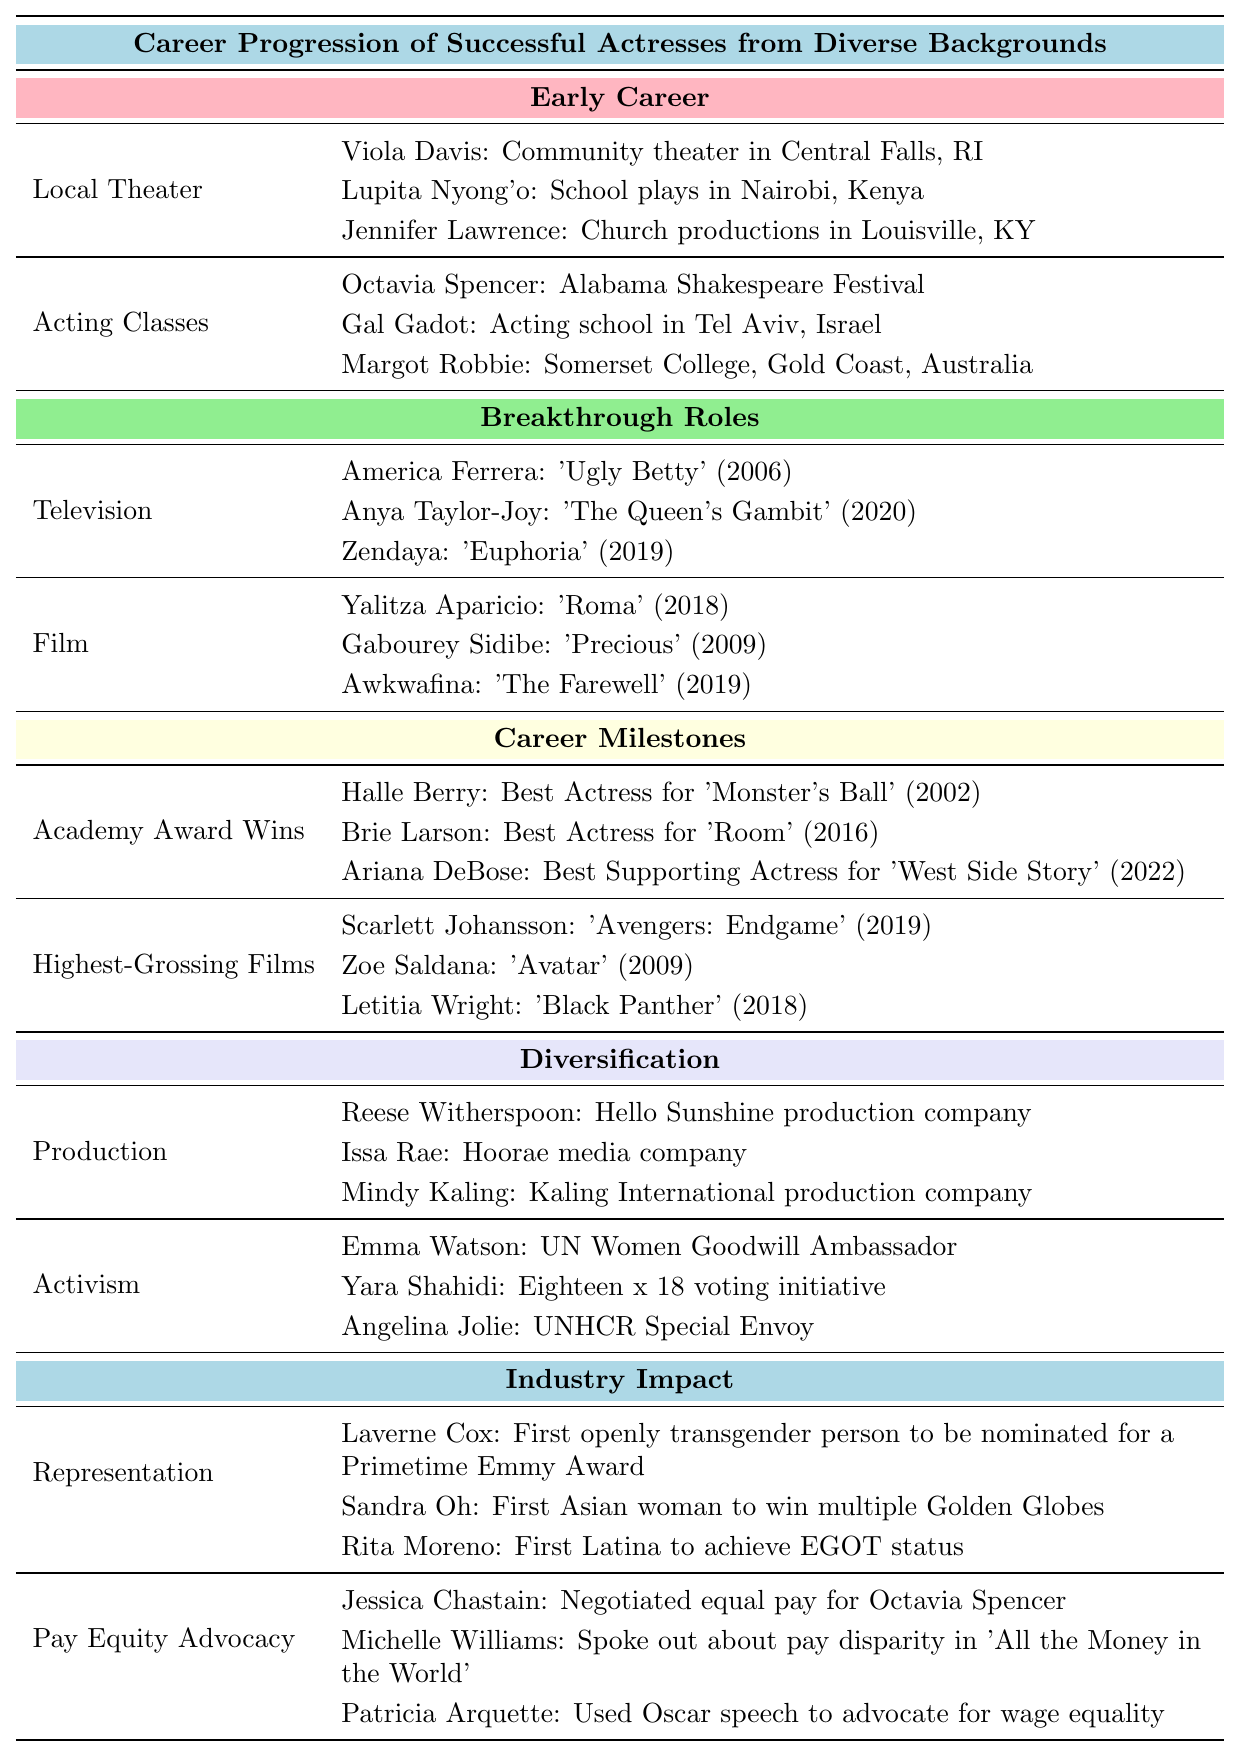What stages are included in the early career section? The early career section lists two stages: Local Theater and Acting Classes. Each stage has examples of successful actresses who started their careers in that area.
Answer: Local Theater and Acting Classes Which actress had a breakthrough role in a film during 2018? The table states that Yalitza Aparicio had a breakthrough role in the film 'Roma' in 2018, as listed under the breakthrough roles section for Film.
Answer: Yalitza Aparicio How many actresses are mentioned in the category of 'Academy Award Wins'? There are three actresses listed in the Academy Award Wins category: Halle Berry, Brie Larson, and Ariana DeBose.
Answer: Three Did any actress from the activism section of diversification win an Academy Award? The table does not indicate that any of the actresses listed in the activism section have won an Academy Award, as only actresses from the Academy Award Wins category mention awards.
Answer: No What type of contributions is Laverne Cox known for according to the industry impact section? Laverne Cox is recognized for her contribution to Representation, where she became the first openly transgender person nominated for a Primetime Emmy Award.
Answer: Representation Which area of diversification has more examples listed? The table shows that the area of Production has three examples, while the area of Activism also has three examples, meaning they are equal.
Answer: They are equal What is the total number of actresses listed in the Breakthrough Roles section? There are six actresses mentioned in the Breakthrough Roles section: three in Television and three in Film, totaling 6.
Answer: 6 Which actress was the first Asian woman to win multiple Golden Globes? The table mentions Sandra Oh as the first Asian woman to win multiple Golden Globes under the Representation category in the Industry Impact section.
Answer: Sandra Oh How does the number of actresses listed under Pay Equity Advocacy compare to those under Representation? There are three actresses listed under Pay Equity Advocacy and three under Representation, making the counts equal.
Answer: They are equal Which actress founded the media company Hoorae? Issa Rae is listed as the founder of Hoorae media company under the Production section of Diversification.
Answer: Issa Rae 